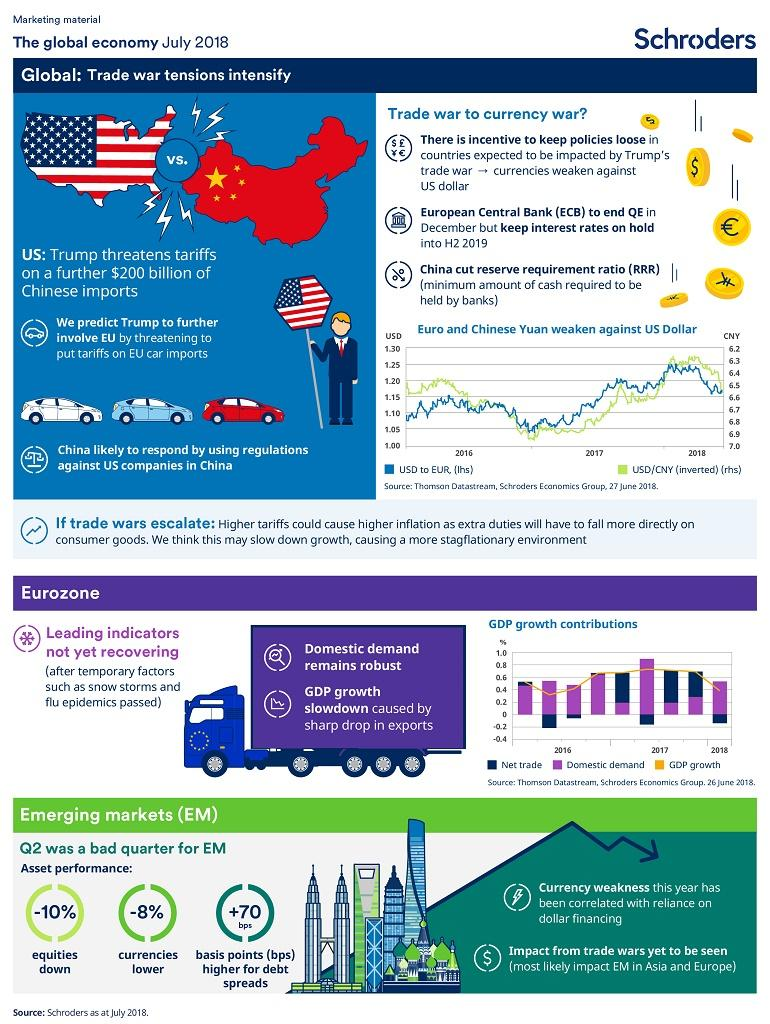Draw attention to some important aspects in this diagram. The use of dollar financing has been associated with currency weakness. Trump is threatening to impose tariffs on EU car imports, which could involve the EU in the ongoing trade war. In the second quarter, stocks decreased by 10%. Temporary factors such as snow storms and flu epidemics can significantly impact the economy. The value of currencies decreased by 8% in the second quarter of the year. 